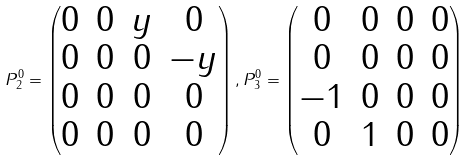Convert formula to latex. <formula><loc_0><loc_0><loc_500><loc_500>P _ { 2 } ^ { 0 } = \begin{pmatrix} 0 & 0 & y & 0 \\ 0 & 0 & 0 & - y \\ 0 & 0 & 0 & 0 \\ 0 & 0 & 0 & 0 \end{pmatrix} , P _ { 3 } ^ { 0 } = \begin{pmatrix} 0 & 0 & 0 & 0 \\ 0 & 0 & 0 & 0 \\ - 1 & 0 & 0 & 0 \\ 0 & 1 & 0 & 0 \end{pmatrix}</formula> 